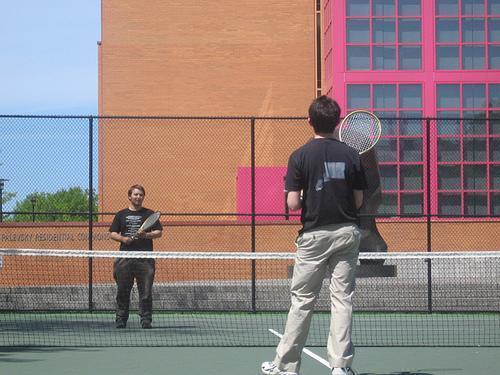How many people are there?
Give a very brief answer. 2. How many people are visible?
Give a very brief answer. 2. How many people can the motorcycle fit on it?
Give a very brief answer. 0. 